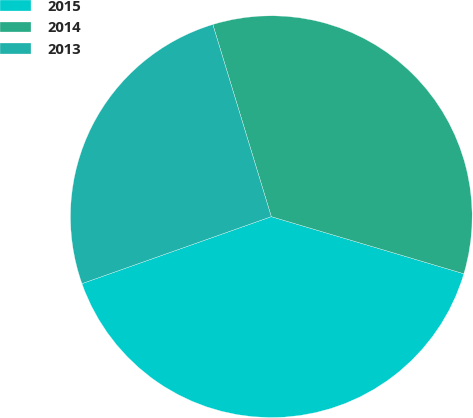Convert chart to OTSL. <chart><loc_0><loc_0><loc_500><loc_500><pie_chart><fcel>2015<fcel>2014<fcel>2013<nl><fcel>40.0%<fcel>34.29%<fcel>25.71%<nl></chart> 